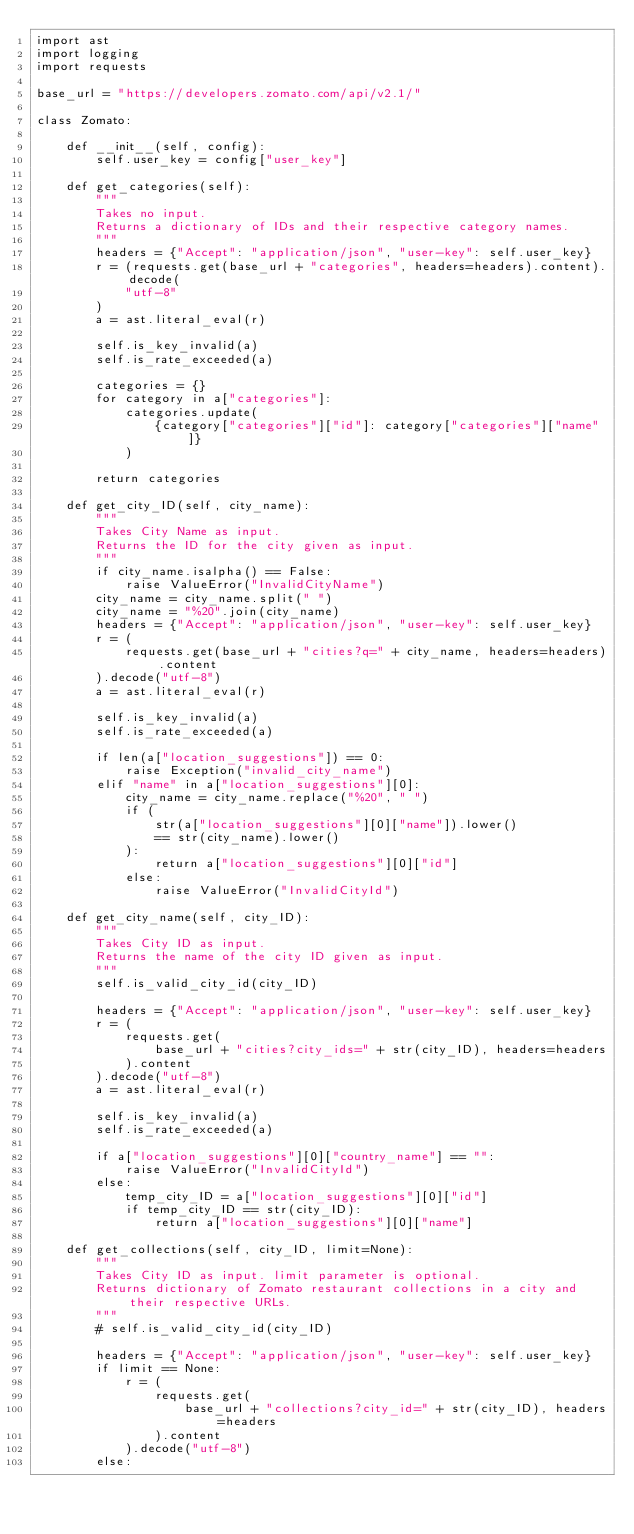Convert code to text. <code><loc_0><loc_0><loc_500><loc_500><_Python_>import ast
import logging
import requests

base_url = "https://developers.zomato.com/api/v2.1/"

class Zomato:

    def __init__(self, config):
        self.user_key = config["user_key"]

    def get_categories(self):
        """
        Takes no input.
        Returns a dictionary of IDs and their respective category names.
        """
        headers = {"Accept": "application/json", "user-key": self.user_key}
        r = (requests.get(base_url + "categories", headers=headers).content).decode(
            "utf-8"
        )
        a = ast.literal_eval(r)

        self.is_key_invalid(a)
        self.is_rate_exceeded(a)

        categories = {}
        for category in a["categories"]:
            categories.update(
                {category["categories"]["id"]: category["categories"]["name"]}
            )

        return categories

    def get_city_ID(self, city_name):
        """
        Takes City Name as input.
        Returns the ID for the city given as input.
        """
        if city_name.isalpha() == False:
            raise ValueError("InvalidCityName")
        city_name = city_name.split(" ")
        city_name = "%20".join(city_name)
        headers = {"Accept": "application/json", "user-key": self.user_key}
        r = (
            requests.get(base_url + "cities?q=" + city_name, headers=headers).content
        ).decode("utf-8")
        a = ast.literal_eval(r)

        self.is_key_invalid(a)
        self.is_rate_exceeded(a)

        if len(a["location_suggestions"]) == 0:
            raise Exception("invalid_city_name")
        elif "name" in a["location_suggestions"][0]:
            city_name = city_name.replace("%20", " ")
            if (
                str(a["location_suggestions"][0]["name"]).lower()
                == str(city_name).lower()
            ):
                return a["location_suggestions"][0]["id"]
            else:
                raise ValueError("InvalidCityId")

    def get_city_name(self, city_ID):
        """
        Takes City ID as input.
        Returns the name of the city ID given as input.
        """
        self.is_valid_city_id(city_ID)

        headers = {"Accept": "application/json", "user-key": self.user_key}
        r = (
            requests.get(
                base_url + "cities?city_ids=" + str(city_ID), headers=headers
            ).content
        ).decode("utf-8")
        a = ast.literal_eval(r)

        self.is_key_invalid(a)
        self.is_rate_exceeded(a)

        if a["location_suggestions"][0]["country_name"] == "":
            raise ValueError("InvalidCityId")
        else:
            temp_city_ID = a["location_suggestions"][0]["id"]
            if temp_city_ID == str(city_ID):
                return a["location_suggestions"][0]["name"]

    def get_collections(self, city_ID, limit=None):
        """
        Takes City ID as input. limit parameter is optional.
        Returns dictionary of Zomato restaurant collections in a city and their respective URLs.
        """
        # self.is_valid_city_id(city_ID)

        headers = {"Accept": "application/json", "user-key": self.user_key}
        if limit == None:
            r = (
                requests.get(
                    base_url + "collections?city_id=" + str(city_ID), headers=headers
                ).content
            ).decode("utf-8")
        else:</code> 